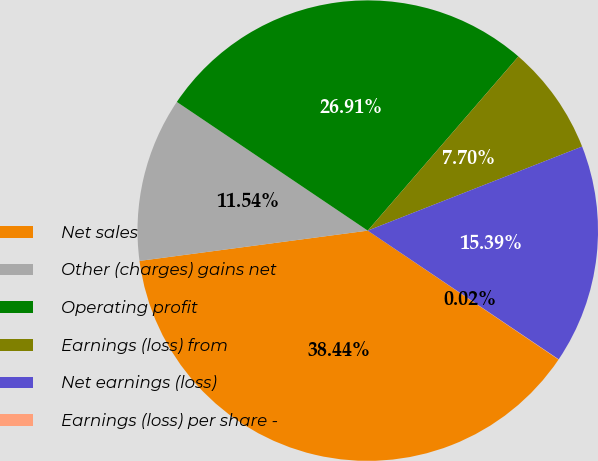Convert chart to OTSL. <chart><loc_0><loc_0><loc_500><loc_500><pie_chart><fcel>Net sales<fcel>Other (charges) gains net<fcel>Operating profit<fcel>Earnings (loss) from<fcel>Net earnings (loss)<fcel>Earnings (loss) per share -<nl><fcel>38.44%<fcel>11.54%<fcel>26.91%<fcel>7.7%<fcel>15.39%<fcel>0.02%<nl></chart> 